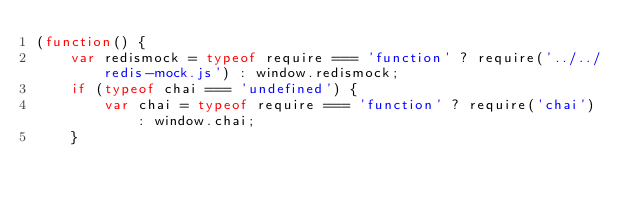Convert code to text. <code><loc_0><loc_0><loc_500><loc_500><_JavaScript_>(function() {
    var redismock = typeof require === 'function' ? require('../../redis-mock.js') : window.redismock;
    if (typeof chai === 'undefined') {
        var chai = typeof require === 'function' ? require('chai') : window.chai;
    }</code> 